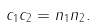<formula> <loc_0><loc_0><loc_500><loc_500>c _ { 1 } c _ { 2 } = n _ { 1 } n _ { 2 } .</formula> 